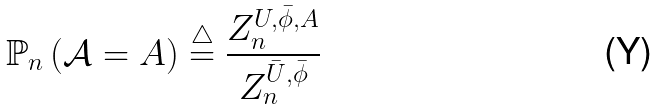<formula> <loc_0><loc_0><loc_500><loc_500>\mathbb { P } _ { n } \left ( \mathcal { A } = A \right ) \overset { \triangle } { = } \frac { Z _ { n } ^ { U , \bar { \phi } , A } } { Z _ { n } ^ { \bar { U } , \bar { \phi } } }</formula> 